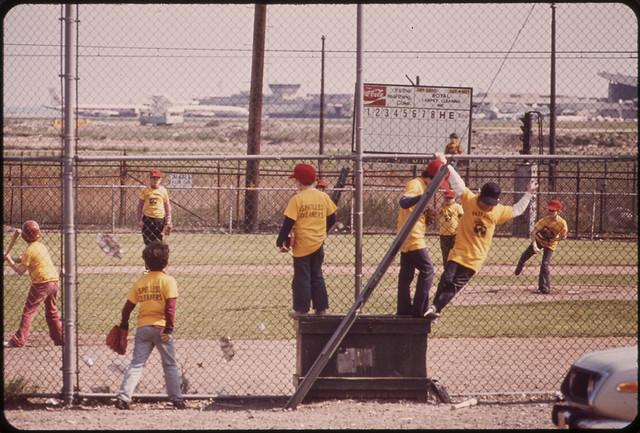What are the items in the background used for?
Concise answer only. Flying. Is this a little league team?
Answer briefly. Yes. What color are the shirts?
Keep it brief. Yellow. 